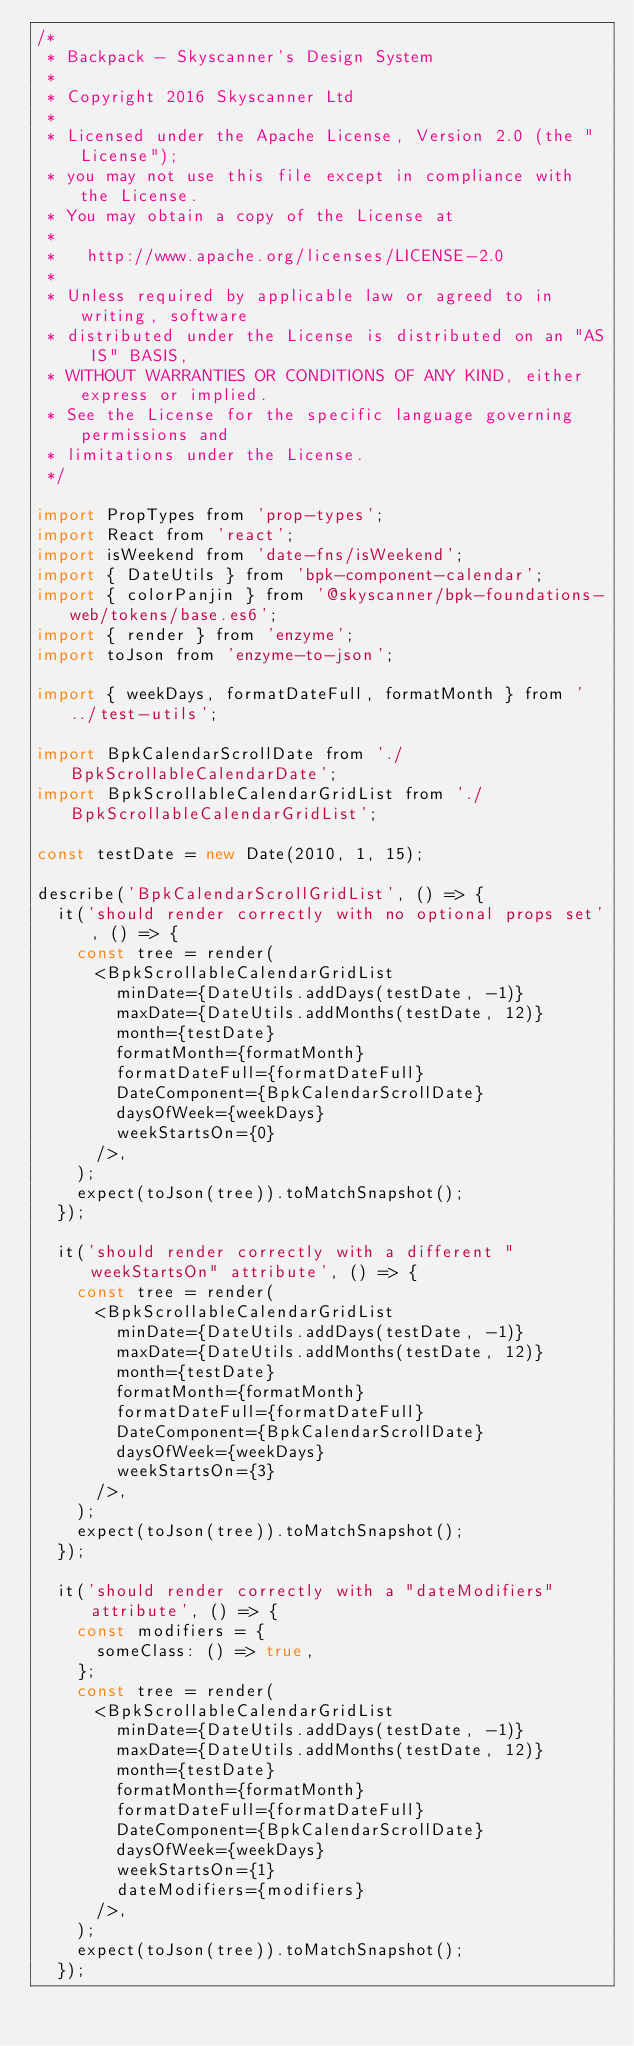Convert code to text. <code><loc_0><loc_0><loc_500><loc_500><_JavaScript_>/*
 * Backpack - Skyscanner's Design System
 *
 * Copyright 2016 Skyscanner Ltd
 *
 * Licensed under the Apache License, Version 2.0 (the "License");
 * you may not use this file except in compliance with the License.
 * You may obtain a copy of the License at
 *
 *   http://www.apache.org/licenses/LICENSE-2.0
 *
 * Unless required by applicable law or agreed to in writing, software
 * distributed under the License is distributed on an "AS IS" BASIS,
 * WITHOUT WARRANTIES OR CONDITIONS OF ANY KIND, either express or implied.
 * See the License for the specific language governing permissions and
 * limitations under the License.
 */

import PropTypes from 'prop-types';
import React from 'react';
import isWeekend from 'date-fns/isWeekend';
import { DateUtils } from 'bpk-component-calendar';
import { colorPanjin } from '@skyscanner/bpk-foundations-web/tokens/base.es6';
import { render } from 'enzyme';
import toJson from 'enzyme-to-json';

import { weekDays, formatDateFull, formatMonth } from '../test-utils';

import BpkCalendarScrollDate from './BpkScrollableCalendarDate';
import BpkScrollableCalendarGridList from './BpkScrollableCalendarGridList';

const testDate = new Date(2010, 1, 15);

describe('BpkCalendarScrollGridList', () => {
  it('should render correctly with no optional props set', () => {
    const tree = render(
      <BpkScrollableCalendarGridList
        minDate={DateUtils.addDays(testDate, -1)}
        maxDate={DateUtils.addMonths(testDate, 12)}
        month={testDate}
        formatMonth={formatMonth}
        formatDateFull={formatDateFull}
        DateComponent={BpkCalendarScrollDate}
        daysOfWeek={weekDays}
        weekStartsOn={0}
      />,
    );
    expect(toJson(tree)).toMatchSnapshot();
  });

  it('should render correctly with a different "weekStartsOn" attribute', () => {
    const tree = render(
      <BpkScrollableCalendarGridList
        minDate={DateUtils.addDays(testDate, -1)}
        maxDate={DateUtils.addMonths(testDate, 12)}
        month={testDate}
        formatMonth={formatMonth}
        formatDateFull={formatDateFull}
        DateComponent={BpkCalendarScrollDate}
        daysOfWeek={weekDays}
        weekStartsOn={3}
      />,
    );
    expect(toJson(tree)).toMatchSnapshot();
  });

  it('should render correctly with a "dateModifiers" attribute', () => {
    const modifiers = {
      someClass: () => true,
    };
    const tree = render(
      <BpkScrollableCalendarGridList
        minDate={DateUtils.addDays(testDate, -1)}
        maxDate={DateUtils.addMonths(testDate, 12)}
        month={testDate}
        formatMonth={formatMonth}
        formatDateFull={formatDateFull}
        DateComponent={BpkCalendarScrollDate}
        daysOfWeek={weekDays}
        weekStartsOn={1}
        dateModifiers={modifiers}
      />,
    );
    expect(toJson(tree)).toMatchSnapshot();
  });
</code> 